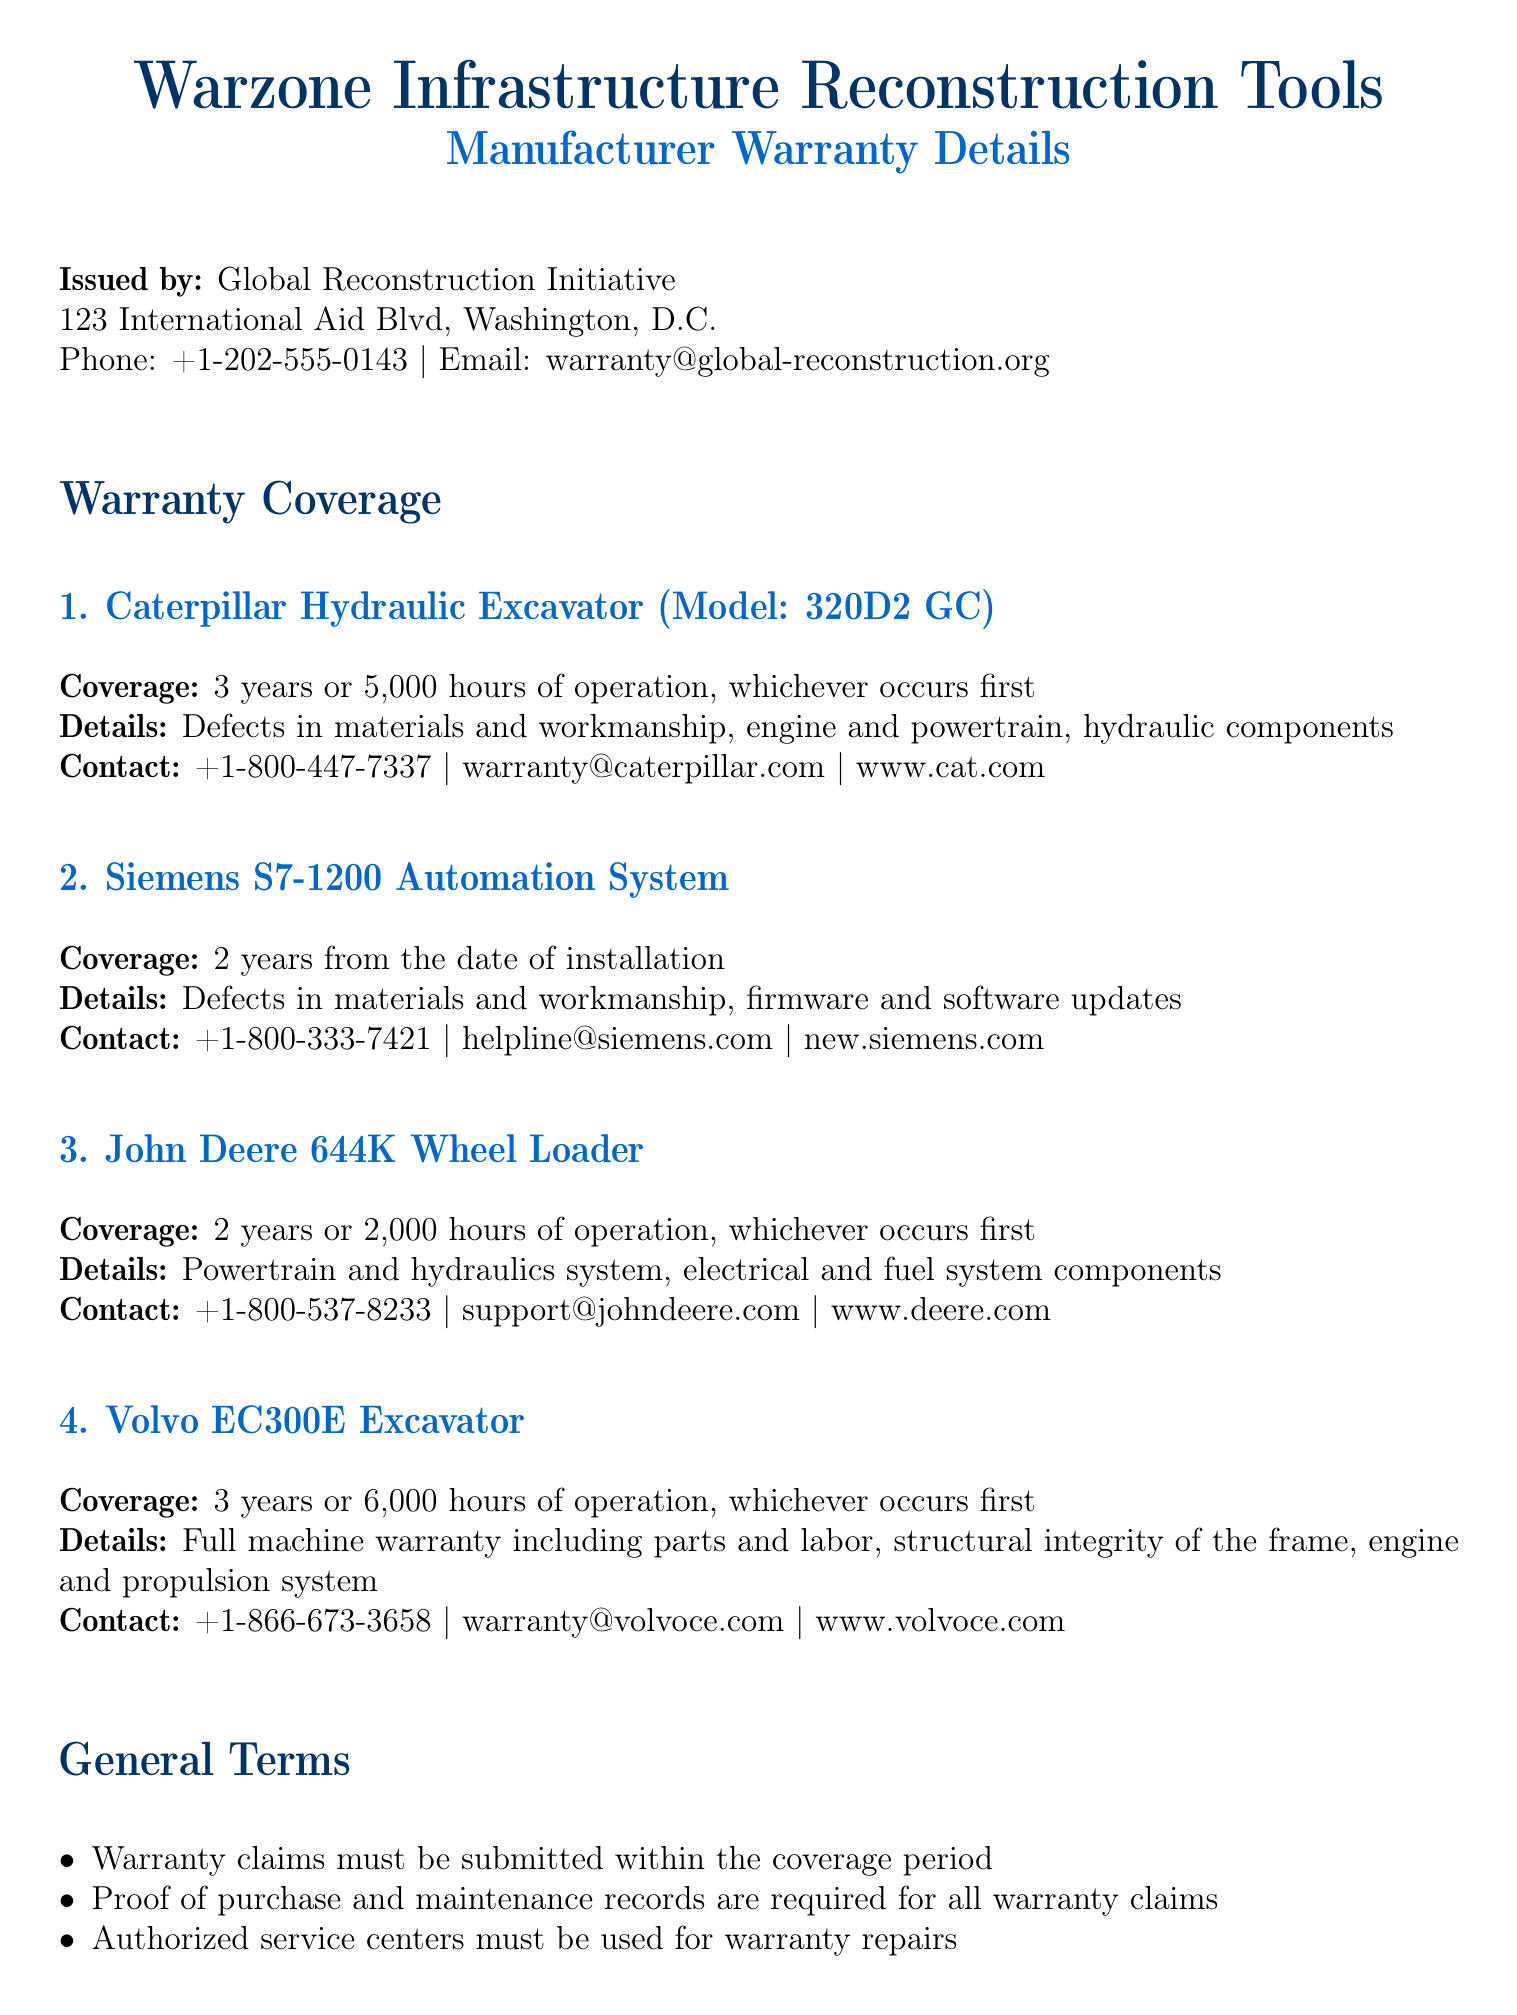What is the warranty coverage for the Caterpillar Hydraulic Excavator? The warranty coverage states 3 years or 5,000 hours of operation, whichever occurs first.
Answer: 3 years or 5,000 hours What components are covered under the John Deere 644K Wheel Loader warranty? The coverage includes powertrain and hydraulics system, electrical and fuel system components.
Answer: Powertrain and hydraulics system, electrical and fuel system What is the contact email for Siemens S7-1200 Automation System warranty inquiries? The document provides the contact email as helpline@siemens.com.
Answer: helpline@siemens.com How many hours of operation does the Volvo EC300E Excavator warranty cover? The warranty coverage states 6,000 hours of operation, or 3 years, whichever occurs first.
Answer: 6,000 hours What is one condition that voids the warranty? The warranty is void if any modifications are made to the equipment without manufacturer's approval.
Answer: Modifications without manufacturer's approval What is the warranty period for the Siemens S7-1200 Automation System? The warranty period is 2 years from the date of installation.
Answer: 2 years What must be provided for all warranty claims? The document states that proof of purchase and maintenance records are required for all warranty claims.
Answer: Proof of purchase and maintenance records Which manufacturer's warranty covers the structural integrity of the frame? The warranty for the Volvo EC300E Excavator covers structural integrity of the frame.
Answer: Volvo EC300E Excavator 